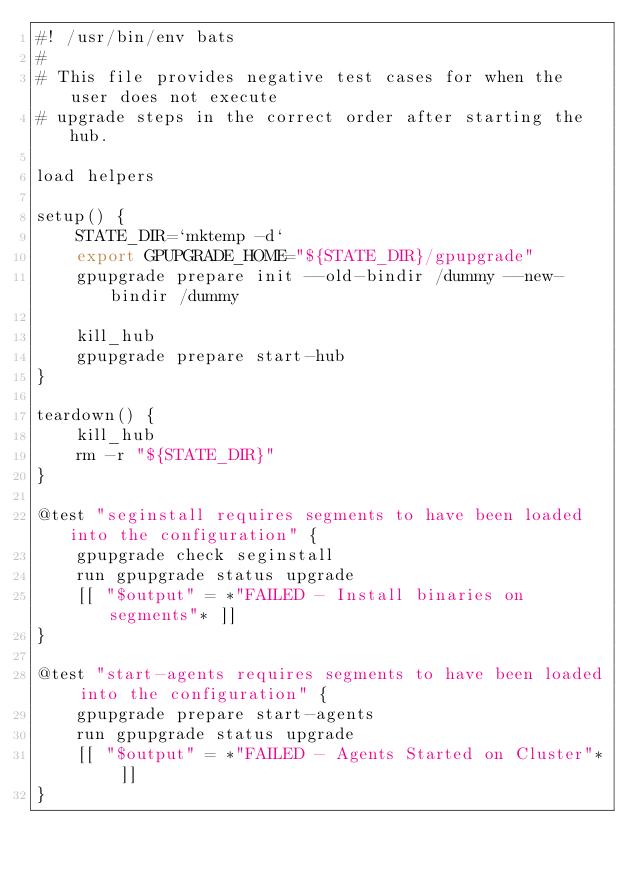Convert code to text. <code><loc_0><loc_0><loc_500><loc_500><_Bash_>#! /usr/bin/env bats
#
# This file provides negative test cases for when the user does not execute
# upgrade steps in the correct order after starting the hub.

load helpers

setup() {
    STATE_DIR=`mktemp -d`
    export GPUPGRADE_HOME="${STATE_DIR}/gpupgrade"
    gpupgrade prepare init --old-bindir /dummy --new-bindir /dummy

    kill_hub
    gpupgrade prepare start-hub
}

teardown() {
    kill_hub
    rm -r "${STATE_DIR}"
}

@test "seginstall requires segments to have been loaded into the configuration" {
    gpupgrade check seginstall
    run gpupgrade status upgrade
    [[ "$output" = *"FAILED - Install binaries on segments"* ]]
}

@test "start-agents requires segments to have been loaded into the configuration" {
    gpupgrade prepare start-agents
    run gpupgrade status upgrade
    [[ "$output" = *"FAILED - Agents Started on Cluster"* ]]
}
</code> 